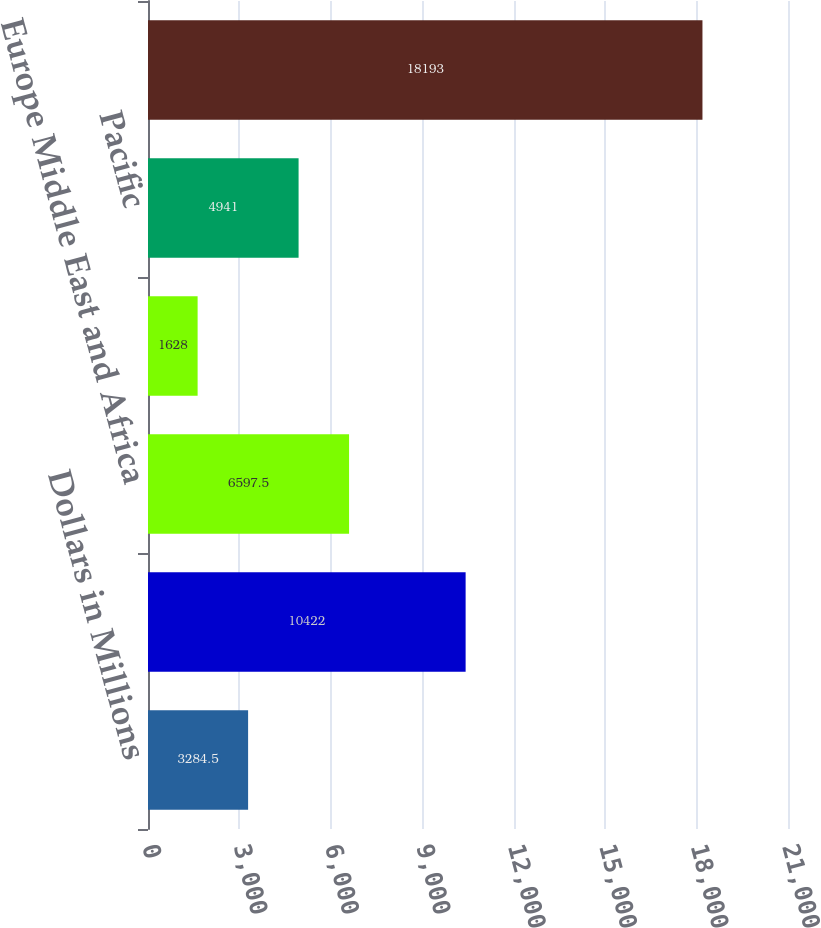Convert chart. <chart><loc_0><loc_0><loc_500><loc_500><bar_chart><fcel>Dollars in Millions<fcel>United States<fcel>Europe Middle East and Africa<fcel>Other Western Hemisphere<fcel>Pacific<fcel>Total<nl><fcel>3284.5<fcel>10422<fcel>6597.5<fcel>1628<fcel>4941<fcel>18193<nl></chart> 